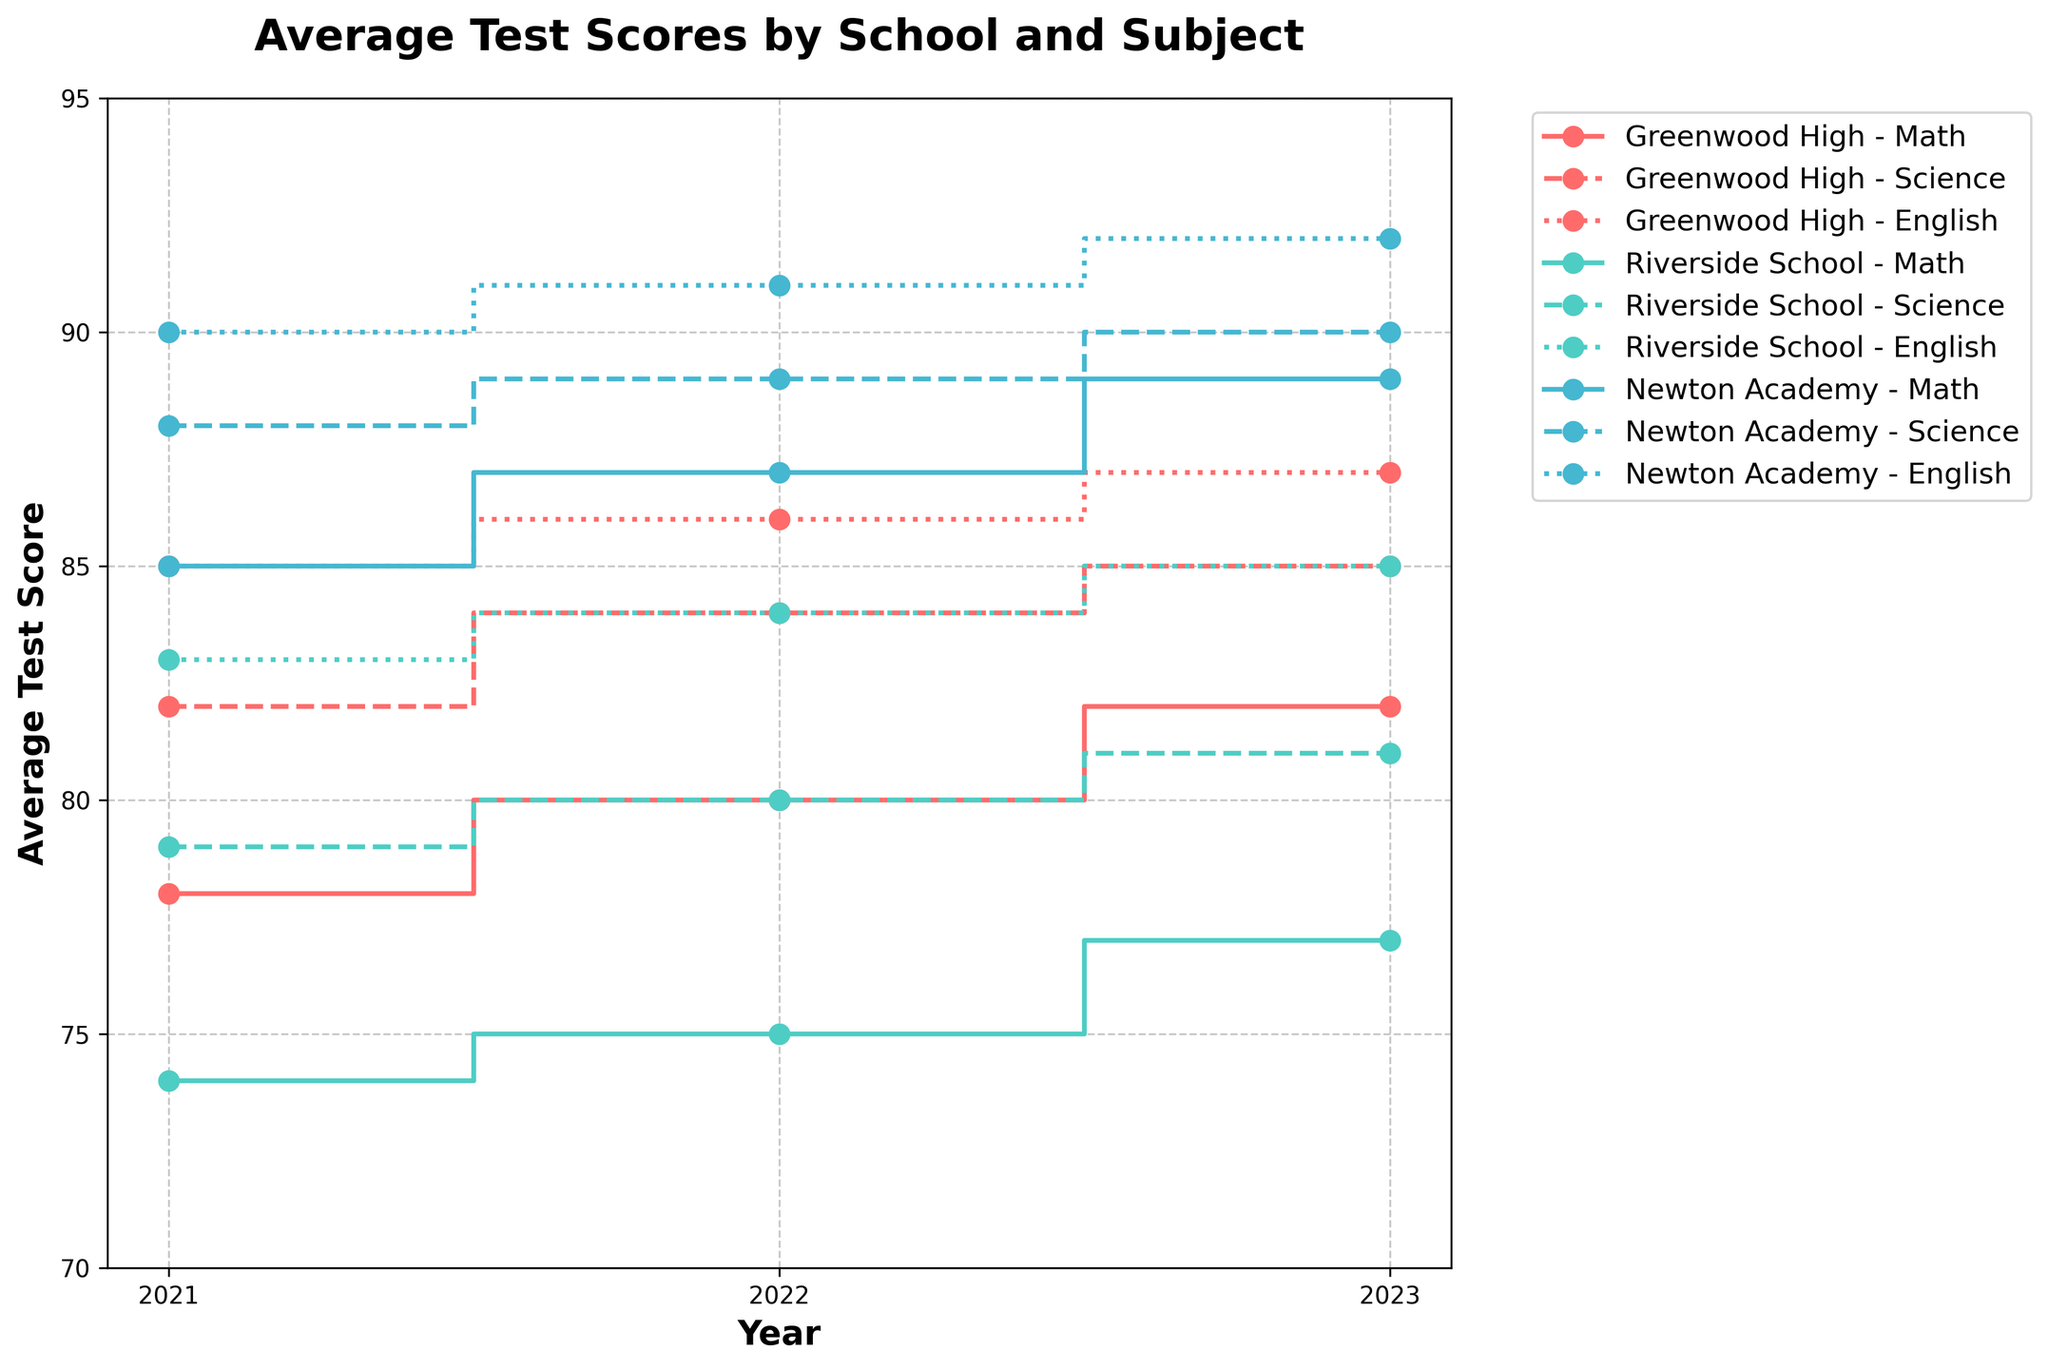What is the title of the figure? The title of the plot is located at the top of the figure and clearly states what the figure is about.
Answer: Average Test Scores by School and Subject How many schools are plotted in the figure? By looking at the legend, which shows the different color lines used for each school, we can see that there are three unique schools plotted.
Answer: Three Which school had the highest average test score in Math in 2023? To answer this, locate the Math lines for each school in 2023 and compare the final data points. Newton Academy's Math score is at 89, which is the highest among the three schools.
Answer: Newton Academy What is the trend of Science scores at Riverside School from 2021 to 2023? Looking at Riverside School's Science line, it starts at 79 in 2021, then increases to 80 in 2022, and further to 81 in 2023, showing a consistent upward trend.
Answer: Increasing Which subject shows the most improvement at Greenwood High from 2021 to 2023? Look at the change for each subject: Math (78 to 82, +4), Science (82 to 85, +3), and English (85 to 87, +2). The Math score increased the most by 4 points.
Answer: Math Which school had the lowest average test score in English in 2022? Looking at the 2022 data points for English, Riverside School has a score of 84 which is lower than Greenwood High (86) and Newton Academy (91).
Answer: Riverside School What's the range of average test scores for Math across all schools in 2023? Find the highest and lowest Math scores: Newton Academy (89), Greenwood High (82), and Riverside School (77). The range is calculated as 89 - 77, which is 12.
Answer: 12 How do the Math scores for Newton Academy compare to the English scores at Riverside School over the three years? Newton Academy's Math scores are consistently higher: Math scores 85, 87, 89 as compared to Riverside's English scores 83, 84, 85 respectively.
Answer: Higher What is the average Science score at Greenwood High over the three years? Add Greenwood High's Science scores from 2021 to 2023 (82 + 84 + 85) and divide by 3: 251 / 3 equals about 83.67.
Answer: 83.67 Identify the subject with the least increase across all schools' average scores between 2021 and 2023. Compare the increases for each subject within each school: For Math (Greenwood High +4, Riverside +3, Newton Academy +4), Science (Greenwood High +3, Riverside +2, Newton Academy +2), and English (Greenwood High +2, Riverside +2, Newton Academy +2). Science shows the least increase.
Answer: Science 